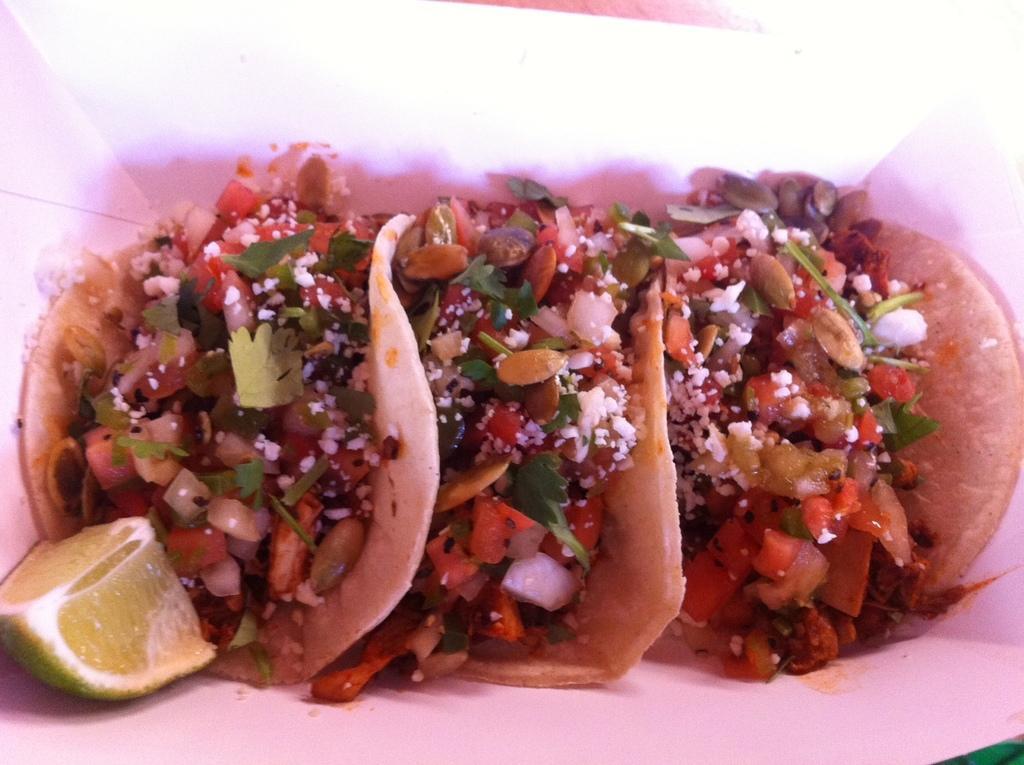How would you summarize this image in a sentence or two? In this image we can see there is a food item and a piece of lemon. 